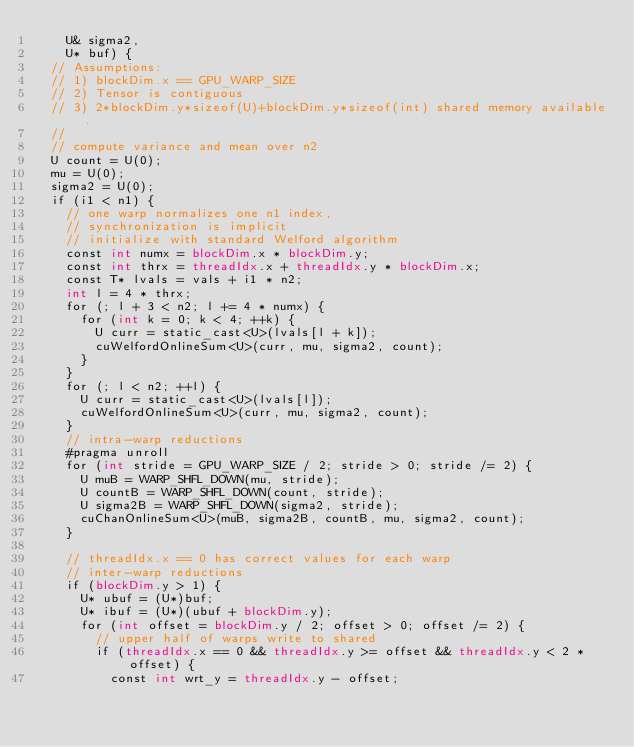<code> <loc_0><loc_0><loc_500><loc_500><_Cuda_>    U& sigma2,
    U* buf) {
  // Assumptions:
  // 1) blockDim.x == GPU_WARP_SIZE
  // 2) Tensor is contiguous
  // 3) 2*blockDim.y*sizeof(U)+blockDim.y*sizeof(int) shared memory available.
  //
  // compute variance and mean over n2
  U count = U(0);
  mu = U(0);
  sigma2 = U(0);
  if (i1 < n1) {
    // one warp normalizes one n1 index,
    // synchronization is implicit
    // initialize with standard Welford algorithm
    const int numx = blockDim.x * blockDim.y;
    const int thrx = threadIdx.x + threadIdx.y * blockDim.x;
    const T* lvals = vals + i1 * n2;
    int l = 4 * thrx;
    for (; l + 3 < n2; l += 4 * numx) {
      for (int k = 0; k < 4; ++k) {
        U curr = static_cast<U>(lvals[l + k]);
        cuWelfordOnlineSum<U>(curr, mu, sigma2, count);
      }
    }
    for (; l < n2; ++l) {
      U curr = static_cast<U>(lvals[l]);
      cuWelfordOnlineSum<U>(curr, mu, sigma2, count);
    }
    // intra-warp reductions
    #pragma unroll
    for (int stride = GPU_WARP_SIZE / 2; stride > 0; stride /= 2) {
      U muB = WARP_SHFL_DOWN(mu, stride);
      U countB = WARP_SHFL_DOWN(count, stride);
      U sigma2B = WARP_SHFL_DOWN(sigma2, stride);
      cuChanOnlineSum<U>(muB, sigma2B, countB, mu, sigma2, count);
    }

    // threadIdx.x == 0 has correct values for each warp
    // inter-warp reductions
    if (blockDim.y > 1) {
      U* ubuf = (U*)buf;
      U* ibuf = (U*)(ubuf + blockDim.y);
      for (int offset = blockDim.y / 2; offset > 0; offset /= 2) {
        // upper half of warps write to shared
        if (threadIdx.x == 0 && threadIdx.y >= offset && threadIdx.y < 2 * offset) {
          const int wrt_y = threadIdx.y - offset;</code> 